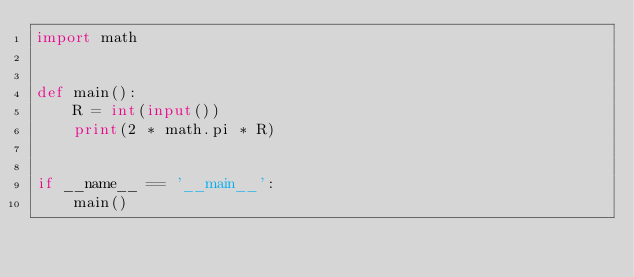<code> <loc_0><loc_0><loc_500><loc_500><_Python_>import math


def main():
    R = int(input())
    print(2 * math.pi * R)


if __name__ == '__main__':
    main()
</code> 